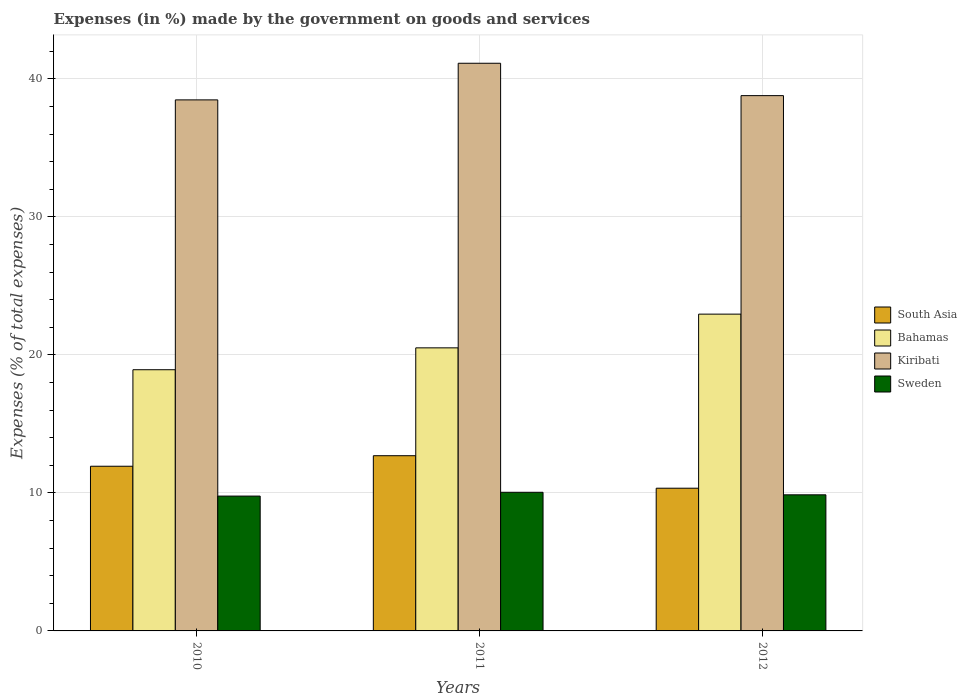How many groups of bars are there?
Your answer should be very brief. 3. Are the number of bars per tick equal to the number of legend labels?
Give a very brief answer. Yes. How many bars are there on the 3rd tick from the right?
Your answer should be compact. 4. What is the percentage of expenses made by the government on goods and services in South Asia in 2010?
Keep it short and to the point. 11.93. Across all years, what is the maximum percentage of expenses made by the government on goods and services in Bahamas?
Offer a very short reply. 22.96. Across all years, what is the minimum percentage of expenses made by the government on goods and services in Bahamas?
Your response must be concise. 18.93. In which year was the percentage of expenses made by the government on goods and services in Bahamas maximum?
Give a very brief answer. 2012. In which year was the percentage of expenses made by the government on goods and services in Bahamas minimum?
Your response must be concise. 2010. What is the total percentage of expenses made by the government on goods and services in Sweden in the graph?
Your answer should be very brief. 29.68. What is the difference between the percentage of expenses made by the government on goods and services in Sweden in 2010 and that in 2012?
Provide a short and direct response. -0.09. What is the difference between the percentage of expenses made by the government on goods and services in Sweden in 2011 and the percentage of expenses made by the government on goods and services in Kiribati in 2012?
Your response must be concise. -28.75. What is the average percentage of expenses made by the government on goods and services in Bahamas per year?
Ensure brevity in your answer.  20.8. In the year 2012, what is the difference between the percentage of expenses made by the government on goods and services in Kiribati and percentage of expenses made by the government on goods and services in South Asia?
Offer a very short reply. 28.45. What is the ratio of the percentage of expenses made by the government on goods and services in South Asia in 2010 to that in 2011?
Ensure brevity in your answer.  0.94. Is the difference between the percentage of expenses made by the government on goods and services in Kiribati in 2010 and 2012 greater than the difference between the percentage of expenses made by the government on goods and services in South Asia in 2010 and 2012?
Offer a terse response. No. What is the difference between the highest and the second highest percentage of expenses made by the government on goods and services in Kiribati?
Ensure brevity in your answer.  2.35. What is the difference between the highest and the lowest percentage of expenses made by the government on goods and services in Bahamas?
Your answer should be very brief. 4.03. Is the sum of the percentage of expenses made by the government on goods and services in South Asia in 2010 and 2012 greater than the maximum percentage of expenses made by the government on goods and services in Kiribati across all years?
Offer a very short reply. No. Is it the case that in every year, the sum of the percentage of expenses made by the government on goods and services in Kiribati and percentage of expenses made by the government on goods and services in Sweden is greater than the sum of percentage of expenses made by the government on goods and services in South Asia and percentage of expenses made by the government on goods and services in Bahamas?
Your answer should be compact. Yes. What does the 2nd bar from the left in 2011 represents?
Provide a succinct answer. Bahamas. What does the 3rd bar from the right in 2010 represents?
Give a very brief answer. Bahamas. Is it the case that in every year, the sum of the percentage of expenses made by the government on goods and services in Kiribati and percentage of expenses made by the government on goods and services in Sweden is greater than the percentage of expenses made by the government on goods and services in Bahamas?
Make the answer very short. Yes. How many bars are there?
Your response must be concise. 12. How many years are there in the graph?
Provide a short and direct response. 3. Are the values on the major ticks of Y-axis written in scientific E-notation?
Offer a terse response. No. Does the graph contain grids?
Your response must be concise. Yes. How many legend labels are there?
Provide a short and direct response. 4. What is the title of the graph?
Your answer should be compact. Expenses (in %) made by the government on goods and services. Does "Curacao" appear as one of the legend labels in the graph?
Your answer should be very brief. No. What is the label or title of the Y-axis?
Provide a succinct answer. Expenses (% of total expenses). What is the Expenses (% of total expenses) of South Asia in 2010?
Offer a terse response. 11.93. What is the Expenses (% of total expenses) of Bahamas in 2010?
Provide a succinct answer. 18.93. What is the Expenses (% of total expenses) of Kiribati in 2010?
Your answer should be compact. 38.49. What is the Expenses (% of total expenses) of Sweden in 2010?
Offer a terse response. 9.77. What is the Expenses (% of total expenses) in South Asia in 2011?
Provide a short and direct response. 12.7. What is the Expenses (% of total expenses) in Bahamas in 2011?
Give a very brief answer. 20.51. What is the Expenses (% of total expenses) in Kiribati in 2011?
Provide a succinct answer. 41.14. What is the Expenses (% of total expenses) of Sweden in 2011?
Offer a very short reply. 10.05. What is the Expenses (% of total expenses) of South Asia in 2012?
Make the answer very short. 10.34. What is the Expenses (% of total expenses) of Bahamas in 2012?
Offer a terse response. 22.96. What is the Expenses (% of total expenses) in Kiribati in 2012?
Make the answer very short. 38.79. What is the Expenses (% of total expenses) of Sweden in 2012?
Keep it short and to the point. 9.86. Across all years, what is the maximum Expenses (% of total expenses) in South Asia?
Your response must be concise. 12.7. Across all years, what is the maximum Expenses (% of total expenses) in Bahamas?
Your response must be concise. 22.96. Across all years, what is the maximum Expenses (% of total expenses) in Kiribati?
Give a very brief answer. 41.14. Across all years, what is the maximum Expenses (% of total expenses) of Sweden?
Your answer should be compact. 10.05. Across all years, what is the minimum Expenses (% of total expenses) in South Asia?
Ensure brevity in your answer.  10.34. Across all years, what is the minimum Expenses (% of total expenses) in Bahamas?
Keep it short and to the point. 18.93. Across all years, what is the minimum Expenses (% of total expenses) of Kiribati?
Provide a short and direct response. 38.49. Across all years, what is the minimum Expenses (% of total expenses) in Sweden?
Your response must be concise. 9.77. What is the total Expenses (% of total expenses) of South Asia in the graph?
Your answer should be compact. 34.97. What is the total Expenses (% of total expenses) of Bahamas in the graph?
Ensure brevity in your answer.  62.4. What is the total Expenses (% of total expenses) of Kiribati in the graph?
Ensure brevity in your answer.  118.42. What is the total Expenses (% of total expenses) of Sweden in the graph?
Offer a very short reply. 29.68. What is the difference between the Expenses (% of total expenses) of South Asia in 2010 and that in 2011?
Offer a very short reply. -0.76. What is the difference between the Expenses (% of total expenses) of Bahamas in 2010 and that in 2011?
Offer a terse response. -1.59. What is the difference between the Expenses (% of total expenses) in Kiribati in 2010 and that in 2011?
Your answer should be very brief. -2.65. What is the difference between the Expenses (% of total expenses) in Sweden in 2010 and that in 2011?
Your response must be concise. -0.28. What is the difference between the Expenses (% of total expenses) of South Asia in 2010 and that in 2012?
Provide a short and direct response. 1.59. What is the difference between the Expenses (% of total expenses) of Bahamas in 2010 and that in 2012?
Your response must be concise. -4.03. What is the difference between the Expenses (% of total expenses) in Kiribati in 2010 and that in 2012?
Offer a terse response. -0.31. What is the difference between the Expenses (% of total expenses) of Sweden in 2010 and that in 2012?
Offer a terse response. -0.09. What is the difference between the Expenses (% of total expenses) of South Asia in 2011 and that in 2012?
Provide a succinct answer. 2.36. What is the difference between the Expenses (% of total expenses) of Bahamas in 2011 and that in 2012?
Your answer should be very brief. -2.44. What is the difference between the Expenses (% of total expenses) of Kiribati in 2011 and that in 2012?
Offer a very short reply. 2.35. What is the difference between the Expenses (% of total expenses) in Sweden in 2011 and that in 2012?
Your answer should be compact. 0.18. What is the difference between the Expenses (% of total expenses) in South Asia in 2010 and the Expenses (% of total expenses) in Bahamas in 2011?
Your answer should be very brief. -8.58. What is the difference between the Expenses (% of total expenses) in South Asia in 2010 and the Expenses (% of total expenses) in Kiribati in 2011?
Make the answer very short. -29.21. What is the difference between the Expenses (% of total expenses) of South Asia in 2010 and the Expenses (% of total expenses) of Sweden in 2011?
Give a very brief answer. 1.89. What is the difference between the Expenses (% of total expenses) in Bahamas in 2010 and the Expenses (% of total expenses) in Kiribati in 2011?
Your answer should be very brief. -22.21. What is the difference between the Expenses (% of total expenses) of Bahamas in 2010 and the Expenses (% of total expenses) of Sweden in 2011?
Make the answer very short. 8.88. What is the difference between the Expenses (% of total expenses) in Kiribati in 2010 and the Expenses (% of total expenses) in Sweden in 2011?
Your response must be concise. 28.44. What is the difference between the Expenses (% of total expenses) of South Asia in 2010 and the Expenses (% of total expenses) of Bahamas in 2012?
Provide a short and direct response. -11.02. What is the difference between the Expenses (% of total expenses) of South Asia in 2010 and the Expenses (% of total expenses) of Kiribati in 2012?
Ensure brevity in your answer.  -26.86. What is the difference between the Expenses (% of total expenses) of South Asia in 2010 and the Expenses (% of total expenses) of Sweden in 2012?
Provide a succinct answer. 2.07. What is the difference between the Expenses (% of total expenses) of Bahamas in 2010 and the Expenses (% of total expenses) of Kiribati in 2012?
Your answer should be compact. -19.86. What is the difference between the Expenses (% of total expenses) of Bahamas in 2010 and the Expenses (% of total expenses) of Sweden in 2012?
Provide a short and direct response. 9.06. What is the difference between the Expenses (% of total expenses) of Kiribati in 2010 and the Expenses (% of total expenses) of Sweden in 2012?
Provide a short and direct response. 28.62. What is the difference between the Expenses (% of total expenses) in South Asia in 2011 and the Expenses (% of total expenses) in Bahamas in 2012?
Your response must be concise. -10.26. What is the difference between the Expenses (% of total expenses) of South Asia in 2011 and the Expenses (% of total expenses) of Kiribati in 2012?
Make the answer very short. -26.1. What is the difference between the Expenses (% of total expenses) in South Asia in 2011 and the Expenses (% of total expenses) in Sweden in 2012?
Your answer should be very brief. 2.83. What is the difference between the Expenses (% of total expenses) of Bahamas in 2011 and the Expenses (% of total expenses) of Kiribati in 2012?
Your answer should be compact. -18.28. What is the difference between the Expenses (% of total expenses) of Bahamas in 2011 and the Expenses (% of total expenses) of Sweden in 2012?
Offer a terse response. 10.65. What is the difference between the Expenses (% of total expenses) in Kiribati in 2011 and the Expenses (% of total expenses) in Sweden in 2012?
Ensure brevity in your answer.  31.28. What is the average Expenses (% of total expenses) in South Asia per year?
Your response must be concise. 11.66. What is the average Expenses (% of total expenses) of Bahamas per year?
Ensure brevity in your answer.  20.8. What is the average Expenses (% of total expenses) in Kiribati per year?
Ensure brevity in your answer.  39.47. What is the average Expenses (% of total expenses) in Sweden per year?
Your response must be concise. 9.89. In the year 2010, what is the difference between the Expenses (% of total expenses) of South Asia and Expenses (% of total expenses) of Bahamas?
Your response must be concise. -6.99. In the year 2010, what is the difference between the Expenses (% of total expenses) of South Asia and Expenses (% of total expenses) of Kiribati?
Offer a very short reply. -26.55. In the year 2010, what is the difference between the Expenses (% of total expenses) in South Asia and Expenses (% of total expenses) in Sweden?
Offer a very short reply. 2.16. In the year 2010, what is the difference between the Expenses (% of total expenses) in Bahamas and Expenses (% of total expenses) in Kiribati?
Provide a short and direct response. -19.56. In the year 2010, what is the difference between the Expenses (% of total expenses) of Bahamas and Expenses (% of total expenses) of Sweden?
Your response must be concise. 9.16. In the year 2010, what is the difference between the Expenses (% of total expenses) in Kiribati and Expenses (% of total expenses) in Sweden?
Give a very brief answer. 28.71. In the year 2011, what is the difference between the Expenses (% of total expenses) of South Asia and Expenses (% of total expenses) of Bahamas?
Make the answer very short. -7.82. In the year 2011, what is the difference between the Expenses (% of total expenses) in South Asia and Expenses (% of total expenses) in Kiribati?
Offer a terse response. -28.44. In the year 2011, what is the difference between the Expenses (% of total expenses) of South Asia and Expenses (% of total expenses) of Sweden?
Make the answer very short. 2.65. In the year 2011, what is the difference between the Expenses (% of total expenses) in Bahamas and Expenses (% of total expenses) in Kiribati?
Your response must be concise. -20.62. In the year 2011, what is the difference between the Expenses (% of total expenses) in Bahamas and Expenses (% of total expenses) in Sweden?
Offer a terse response. 10.47. In the year 2011, what is the difference between the Expenses (% of total expenses) in Kiribati and Expenses (% of total expenses) in Sweden?
Your answer should be compact. 31.09. In the year 2012, what is the difference between the Expenses (% of total expenses) of South Asia and Expenses (% of total expenses) of Bahamas?
Provide a short and direct response. -12.62. In the year 2012, what is the difference between the Expenses (% of total expenses) of South Asia and Expenses (% of total expenses) of Kiribati?
Your response must be concise. -28.45. In the year 2012, what is the difference between the Expenses (% of total expenses) of South Asia and Expenses (% of total expenses) of Sweden?
Give a very brief answer. 0.48. In the year 2012, what is the difference between the Expenses (% of total expenses) of Bahamas and Expenses (% of total expenses) of Kiribati?
Provide a succinct answer. -15.84. In the year 2012, what is the difference between the Expenses (% of total expenses) in Bahamas and Expenses (% of total expenses) in Sweden?
Provide a short and direct response. 13.09. In the year 2012, what is the difference between the Expenses (% of total expenses) of Kiribati and Expenses (% of total expenses) of Sweden?
Offer a terse response. 28.93. What is the ratio of the Expenses (% of total expenses) in South Asia in 2010 to that in 2011?
Provide a succinct answer. 0.94. What is the ratio of the Expenses (% of total expenses) in Bahamas in 2010 to that in 2011?
Provide a succinct answer. 0.92. What is the ratio of the Expenses (% of total expenses) in Kiribati in 2010 to that in 2011?
Provide a short and direct response. 0.94. What is the ratio of the Expenses (% of total expenses) of Sweden in 2010 to that in 2011?
Ensure brevity in your answer.  0.97. What is the ratio of the Expenses (% of total expenses) of South Asia in 2010 to that in 2012?
Your answer should be very brief. 1.15. What is the ratio of the Expenses (% of total expenses) of Bahamas in 2010 to that in 2012?
Offer a very short reply. 0.82. What is the ratio of the Expenses (% of total expenses) in Kiribati in 2010 to that in 2012?
Keep it short and to the point. 0.99. What is the ratio of the Expenses (% of total expenses) of Sweden in 2010 to that in 2012?
Your answer should be very brief. 0.99. What is the ratio of the Expenses (% of total expenses) in South Asia in 2011 to that in 2012?
Make the answer very short. 1.23. What is the ratio of the Expenses (% of total expenses) of Bahamas in 2011 to that in 2012?
Your answer should be compact. 0.89. What is the ratio of the Expenses (% of total expenses) in Kiribati in 2011 to that in 2012?
Offer a terse response. 1.06. What is the ratio of the Expenses (% of total expenses) in Sweden in 2011 to that in 2012?
Keep it short and to the point. 1.02. What is the difference between the highest and the second highest Expenses (% of total expenses) of South Asia?
Provide a succinct answer. 0.76. What is the difference between the highest and the second highest Expenses (% of total expenses) in Bahamas?
Provide a succinct answer. 2.44. What is the difference between the highest and the second highest Expenses (% of total expenses) in Kiribati?
Your answer should be very brief. 2.35. What is the difference between the highest and the second highest Expenses (% of total expenses) of Sweden?
Your answer should be compact. 0.18. What is the difference between the highest and the lowest Expenses (% of total expenses) in South Asia?
Offer a very short reply. 2.36. What is the difference between the highest and the lowest Expenses (% of total expenses) of Bahamas?
Provide a short and direct response. 4.03. What is the difference between the highest and the lowest Expenses (% of total expenses) of Kiribati?
Your answer should be compact. 2.65. What is the difference between the highest and the lowest Expenses (% of total expenses) of Sweden?
Give a very brief answer. 0.28. 